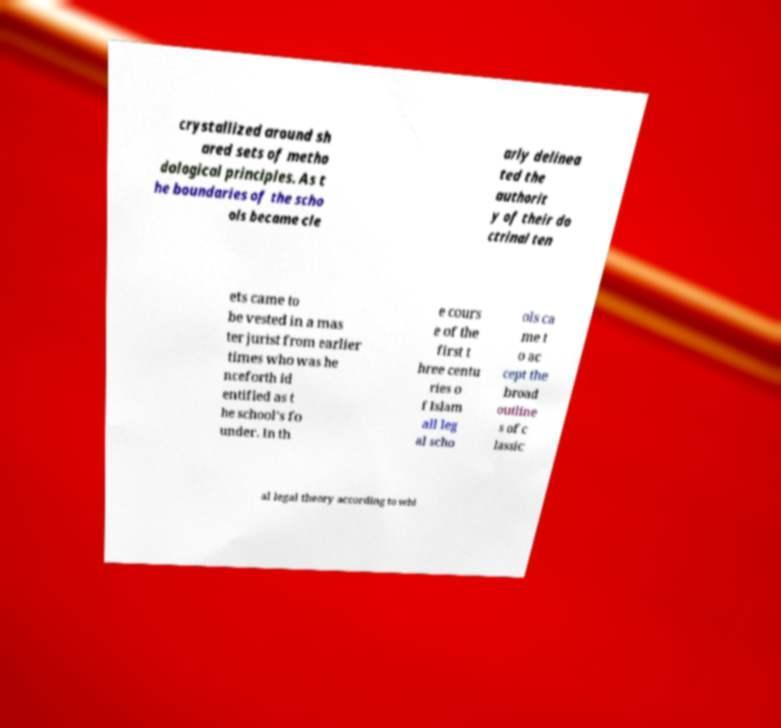Can you accurately transcribe the text from the provided image for me? crystallized around sh ared sets of metho dological principles. As t he boundaries of the scho ols became cle arly delinea ted the authorit y of their do ctrinal ten ets came to be vested in a mas ter jurist from earlier times who was he nceforth id entified as t he school's fo under. In th e cours e of the first t hree centu ries o f Islam all leg al scho ols ca me t o ac cept the broad outline s of c lassic al legal theory according to whi 